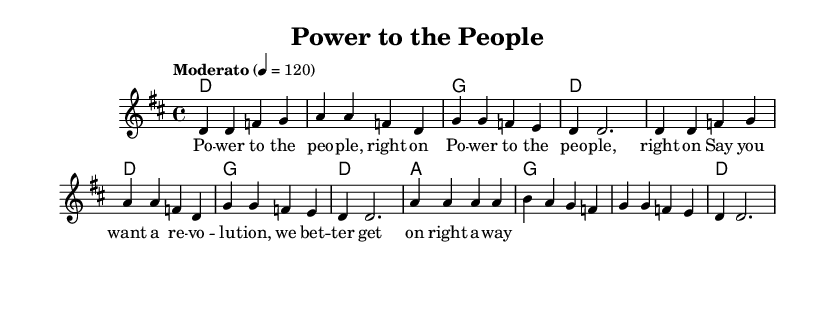What is the key signature of this music? The key signature is D major, indicated by two sharps on the staff (F# and C#).
Answer: D major What is the time signature of this music? The time signature is 4/4, which is shown as a fraction at the beginning of the staff. This means there are four beats in each measure.
Answer: 4/4 What is the tempo marking for this piece? The tempo is marked as "Moderato," which indicates a moderate pace, and the number "4 = 120" indicates that a quarter note gets 120 beats per minute.
Answer: Moderato How many measures are in the melody? The melody consists of a total of 8 measures, as indicated by the 8 sets of bar lines.
Answer: 8 What chords are used in the first verse? The chords used in the verse are D major, G major, and A major. These can be found in the chord names above the staff in the score.
Answer: D major, G major, A major How does the melody reflect the lyrics' theme of empowerment? The melody features strong, repetitive phrases that emphasize the lyrics "Power to the people," which reinforces the theme of empowerment and rallying. This is evident in the melodic contour and rhythmic emphasis.
Answer: Strong and repetitive What is the final note of the melody in this piece? The final note of the melody is a half note D, as seen at the end of the last measure where the melody concludes.
Answer: D 